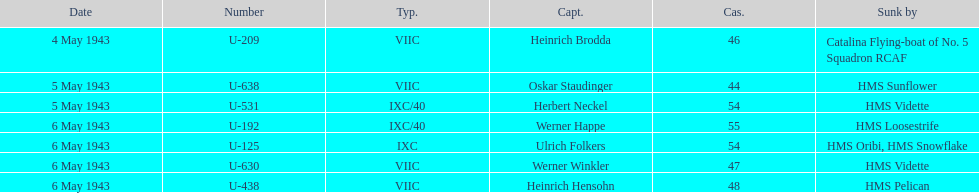Which vessel was responsible for sinking the highest number of u-boats? HMS Vidette. 